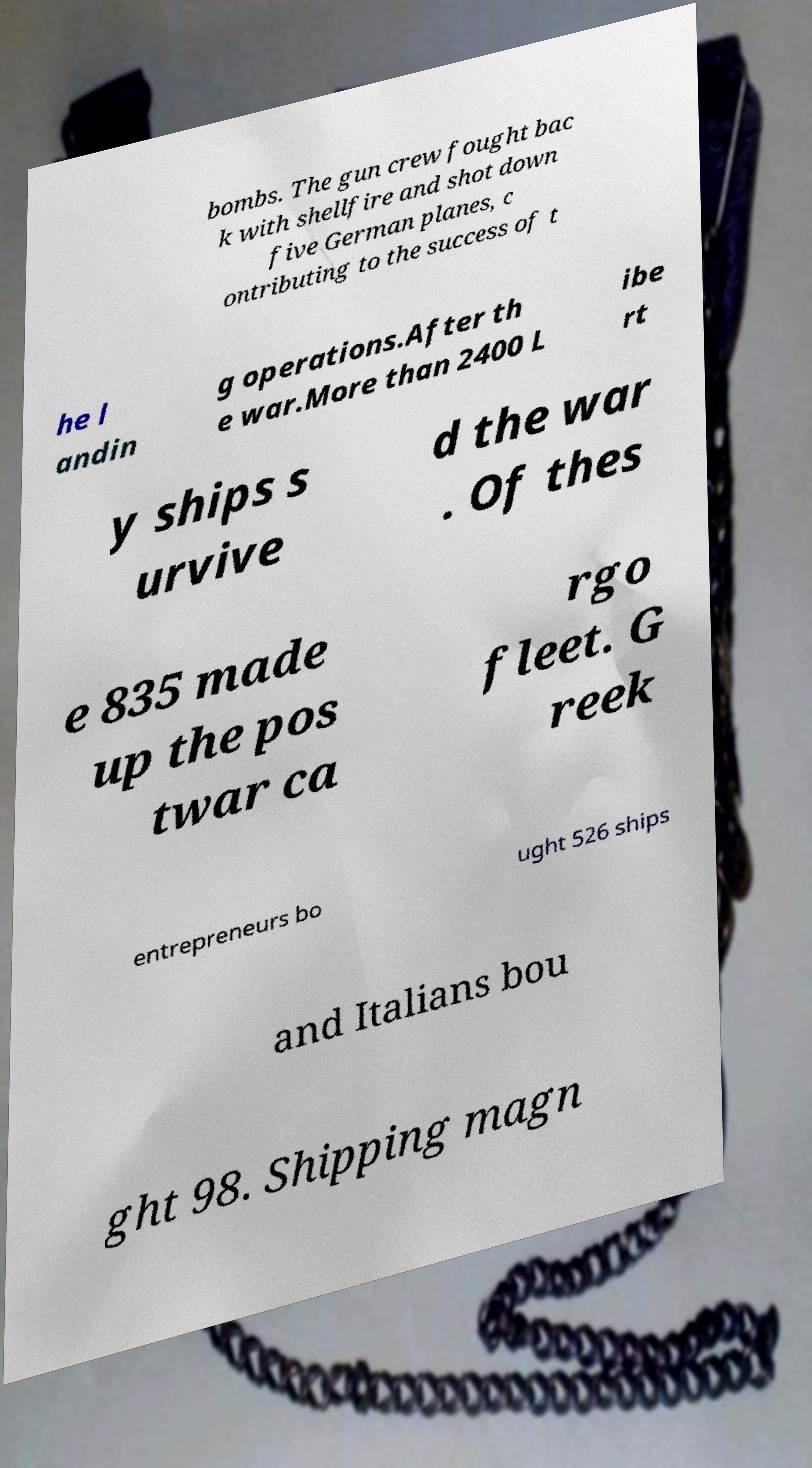Please read and relay the text visible in this image. What does it say? bombs. The gun crew fought bac k with shellfire and shot down five German planes, c ontributing to the success of t he l andin g operations.After th e war.More than 2400 L ibe rt y ships s urvive d the war . Of thes e 835 made up the pos twar ca rgo fleet. G reek entrepreneurs bo ught 526 ships and Italians bou ght 98. Shipping magn 